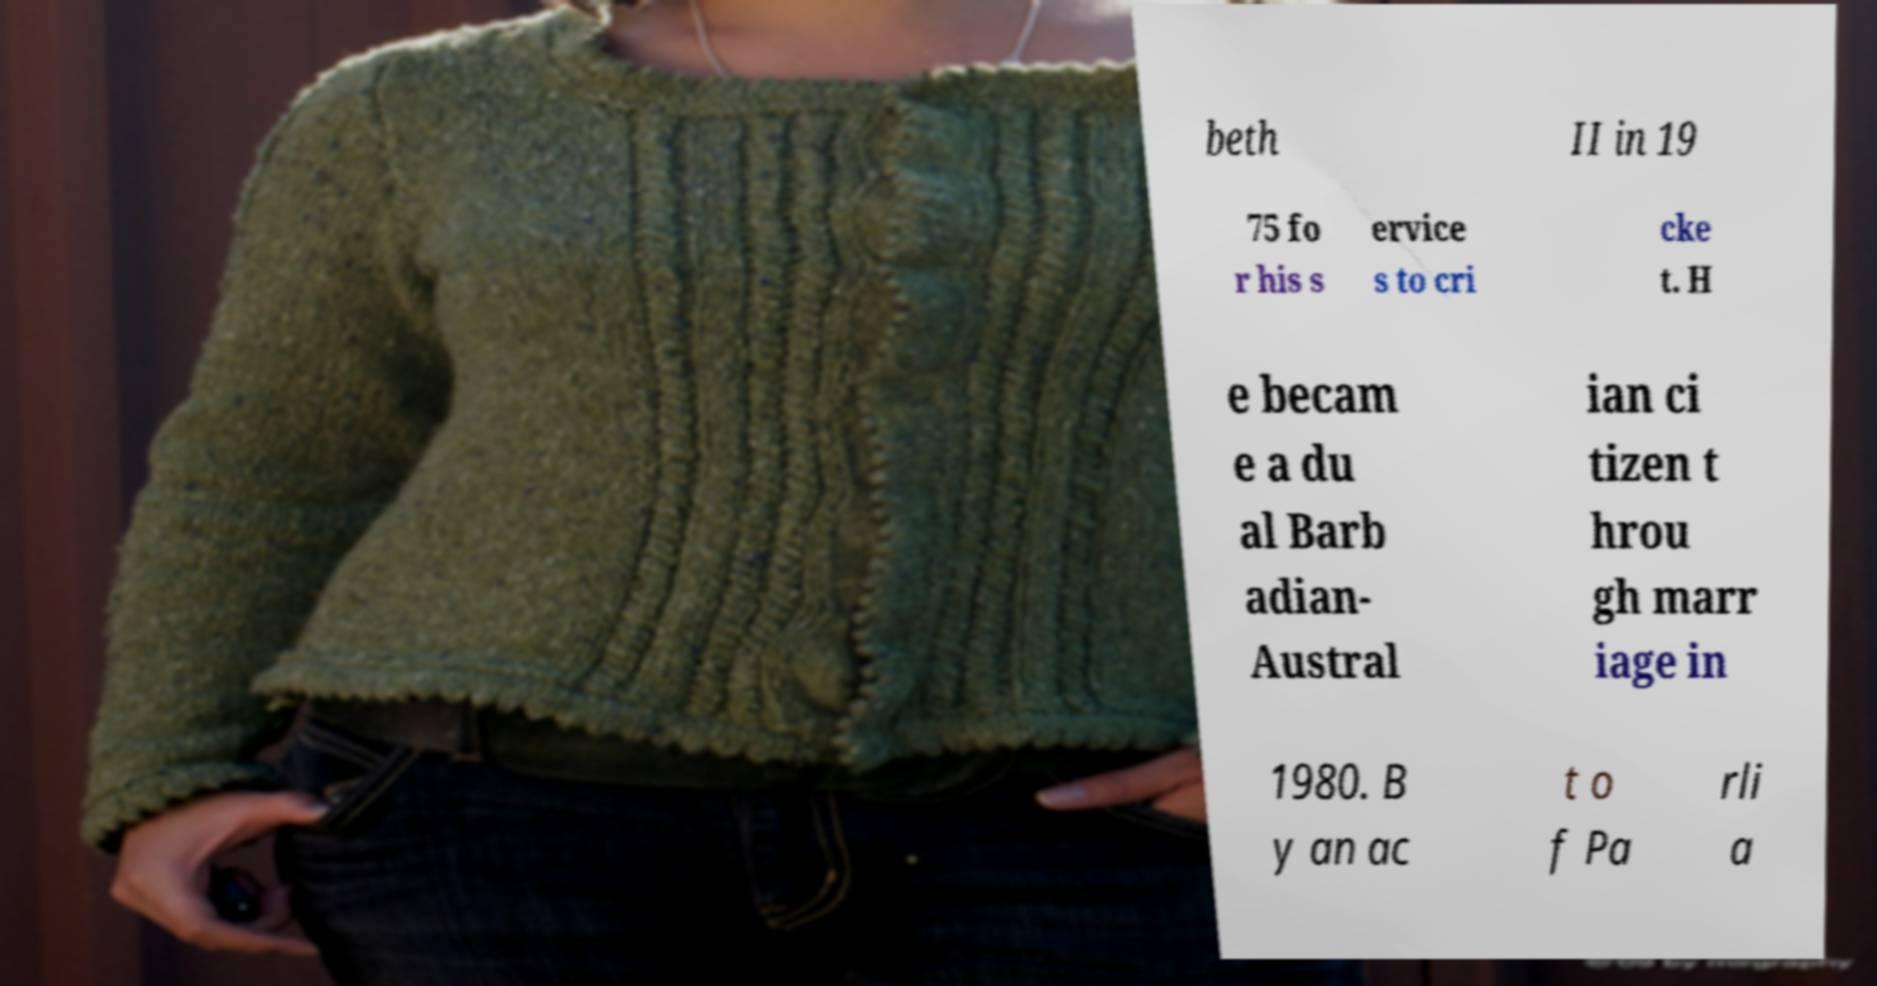Could you extract and type out the text from this image? beth II in 19 75 fo r his s ervice s to cri cke t. H e becam e a du al Barb adian- Austral ian ci tizen t hrou gh marr iage in 1980. B y an ac t o f Pa rli a 